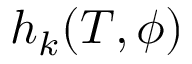Convert formula to latex. <formula><loc_0><loc_0><loc_500><loc_500>h _ { k } ( T , \phi )</formula> 